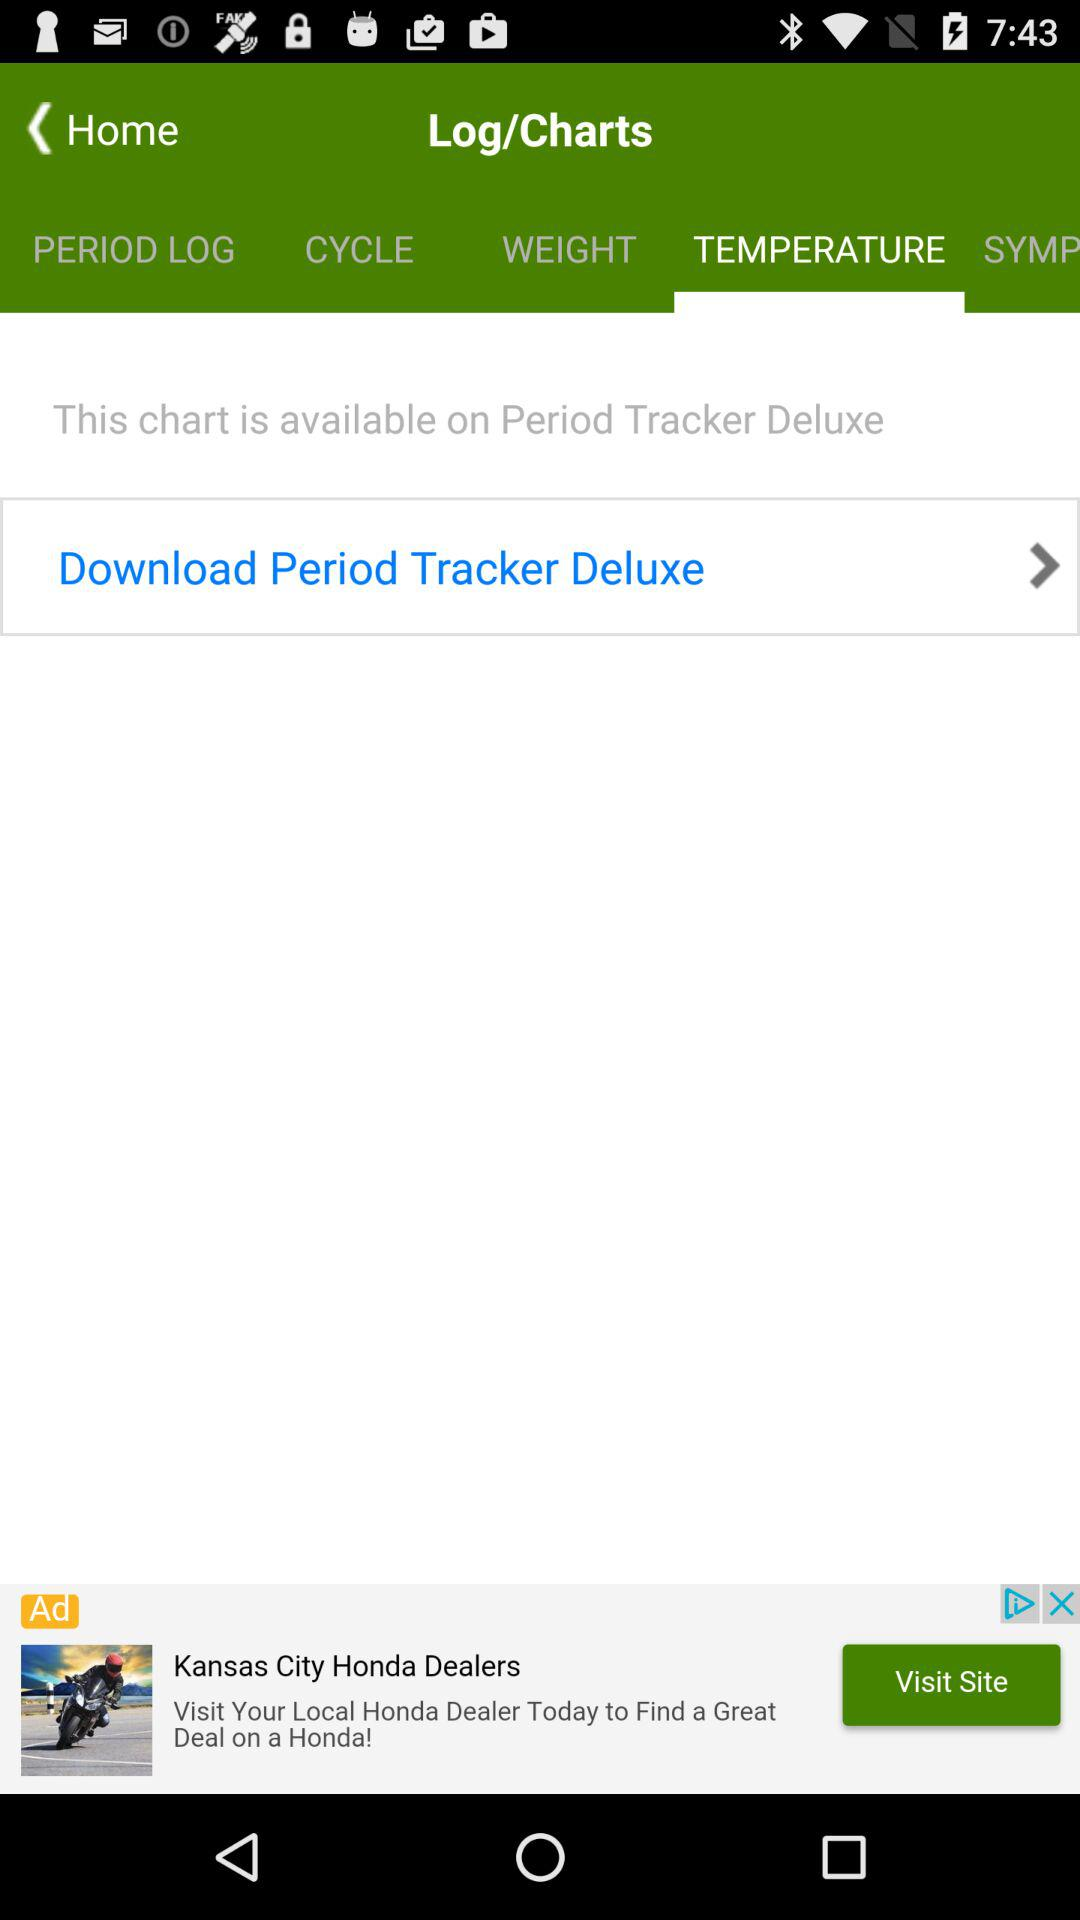Which tab is selected? The selected tab is "TEMPERATURE". 